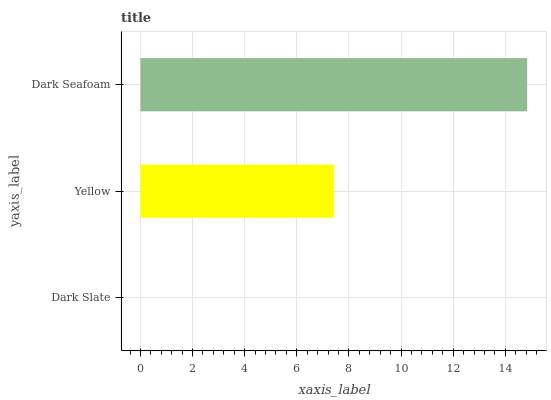Is Dark Slate the minimum?
Answer yes or no. Yes. Is Dark Seafoam the maximum?
Answer yes or no. Yes. Is Yellow the minimum?
Answer yes or no. No. Is Yellow the maximum?
Answer yes or no. No. Is Yellow greater than Dark Slate?
Answer yes or no. Yes. Is Dark Slate less than Yellow?
Answer yes or no. Yes. Is Dark Slate greater than Yellow?
Answer yes or no. No. Is Yellow less than Dark Slate?
Answer yes or no. No. Is Yellow the high median?
Answer yes or no. Yes. Is Yellow the low median?
Answer yes or no. Yes. Is Dark Seafoam the high median?
Answer yes or no. No. Is Dark Slate the low median?
Answer yes or no. No. 